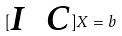Convert formula to latex. <formula><loc_0><loc_0><loc_500><loc_500>[ \begin{matrix} I & C \end{matrix} ] X = b</formula> 